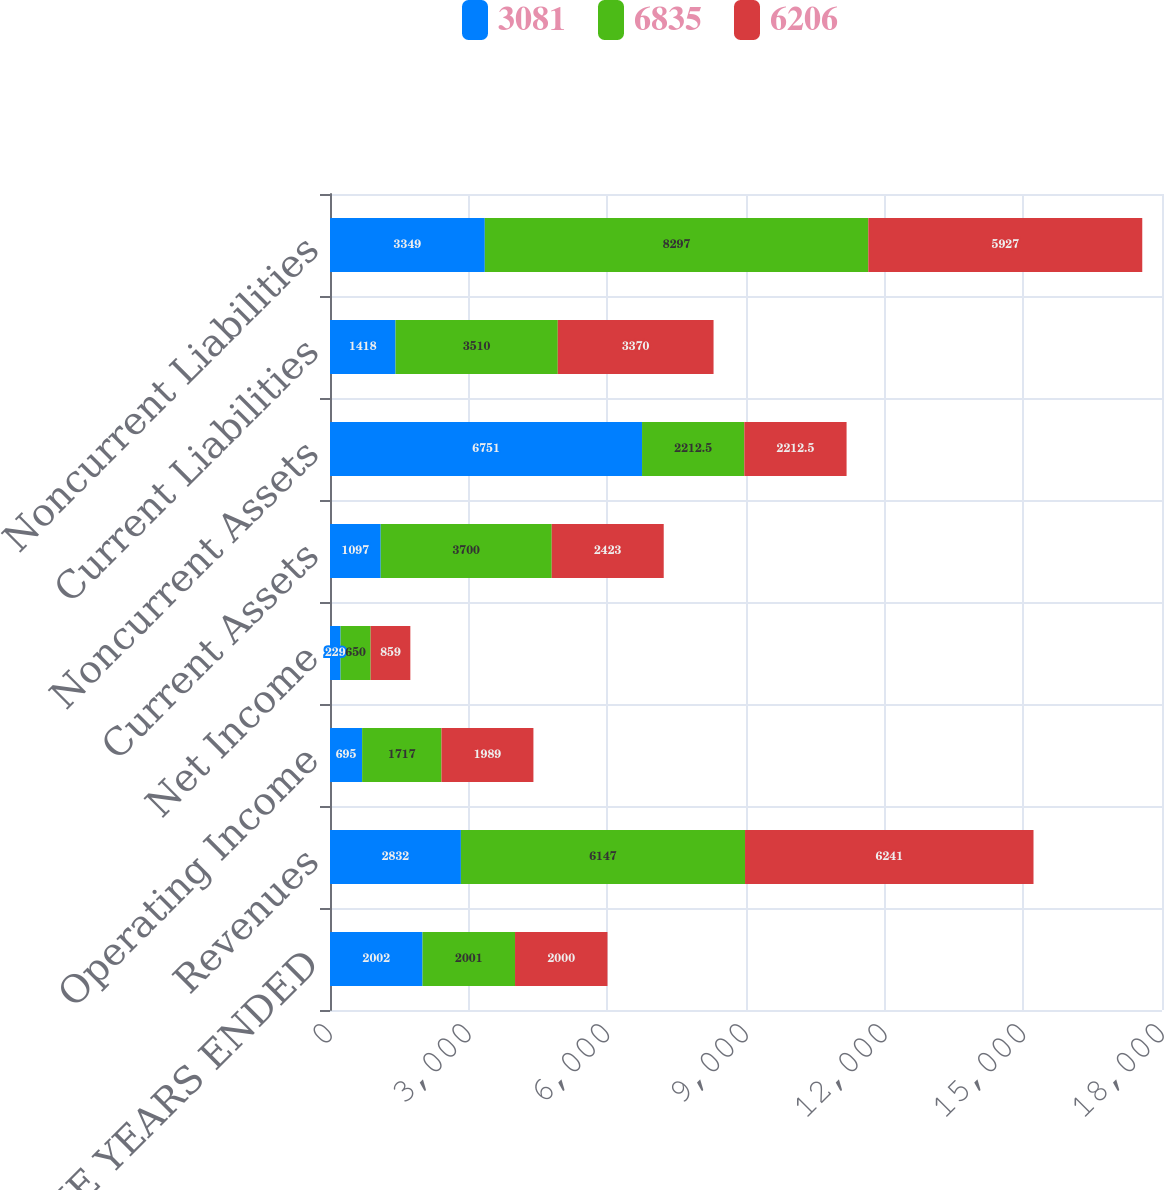Convert chart. <chart><loc_0><loc_0><loc_500><loc_500><stacked_bar_chart><ecel><fcel>AS OF AND FOR THE YEARS ENDED<fcel>Revenues<fcel>Operating Income<fcel>Net Income<fcel>Current Assets<fcel>Noncurrent Assets<fcel>Current Liabilities<fcel>Noncurrent Liabilities<nl><fcel>3081<fcel>2002<fcel>2832<fcel>695<fcel>229<fcel>1097<fcel>6751<fcel>1418<fcel>3349<nl><fcel>6835<fcel>2001<fcel>6147<fcel>1717<fcel>650<fcel>3700<fcel>2212.5<fcel>3510<fcel>8297<nl><fcel>6206<fcel>2000<fcel>6241<fcel>1989<fcel>859<fcel>2423<fcel>2212.5<fcel>3370<fcel>5927<nl></chart> 